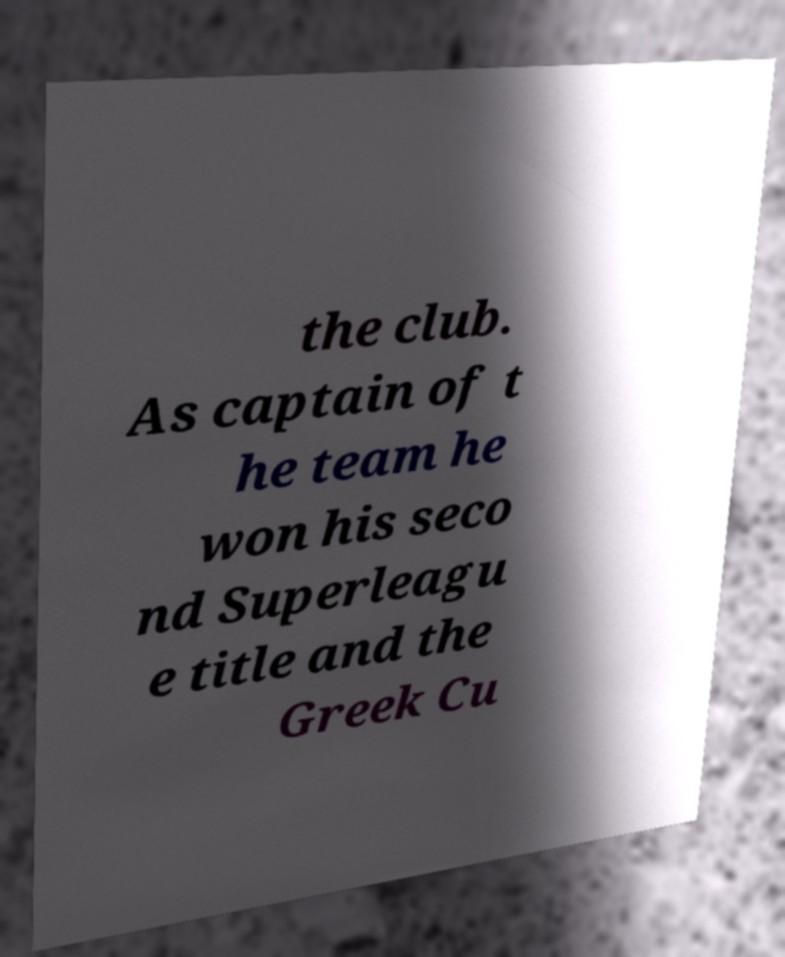Could you assist in decoding the text presented in this image and type it out clearly? the club. As captain of t he team he won his seco nd Superleagu e title and the Greek Cu 